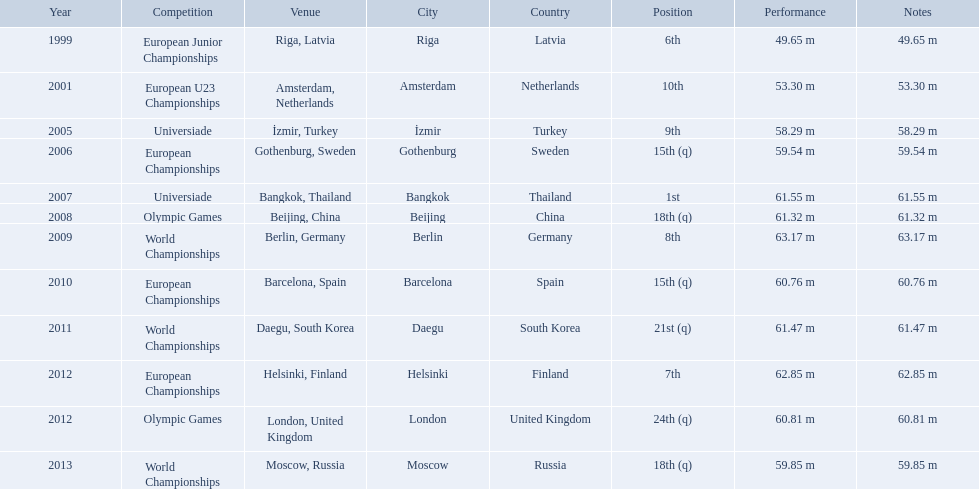What are the years listed prior to 2007? 1999, 2001, 2005, 2006. What are their corresponding finishes? 6th, 10th, 9th, 15th (q). Which is the highest? 6th. What were the distances of mayer's throws? 49.65 m, 53.30 m, 58.29 m, 59.54 m, 61.55 m, 61.32 m, 63.17 m, 60.76 m, 61.47 m, 62.85 m, 60.81 m, 59.85 m. Which of these went the farthest? 63.17 m. 